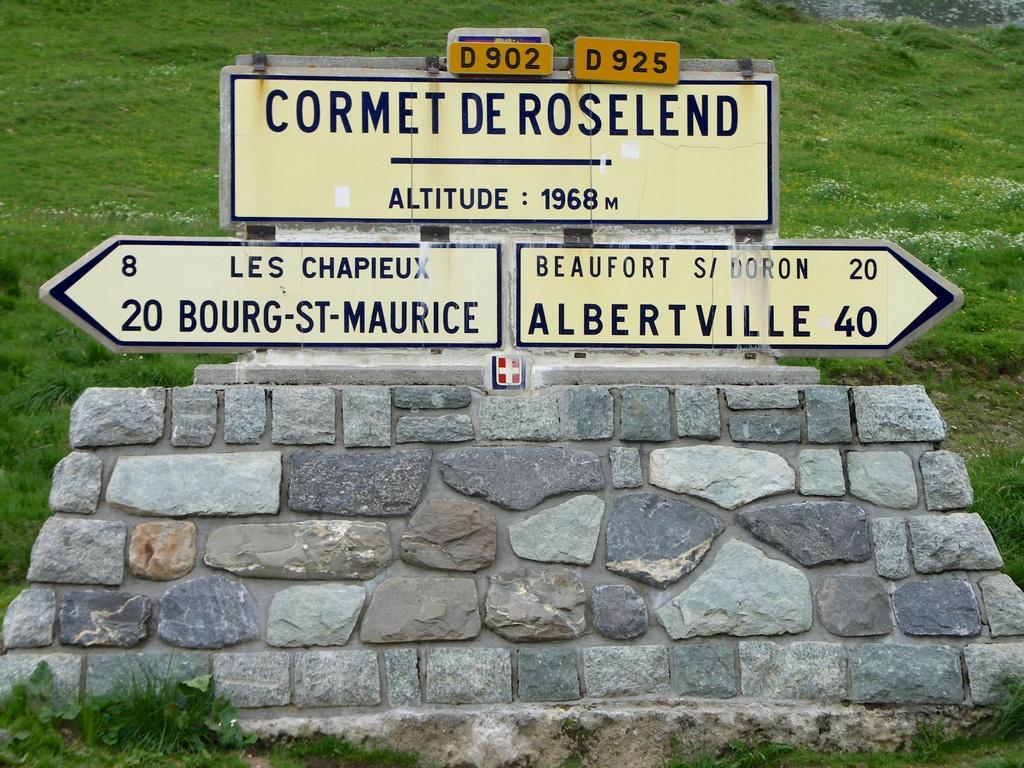<image>
Offer a succinct explanation of the picture presented. the word cormet on top of one of the signs 